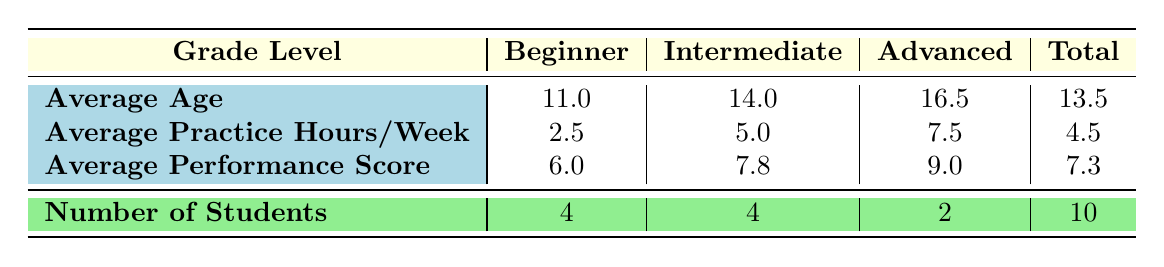What is the average age of intermediate level students? There are 4 intermediate level students: Liam Chen (15), Mason Lee (14), Isabella Wright (12), and Ava Johnson (13). To find the average, we add their ages: 15 + 14 + 12 + 13 = 54 and then divide by the number of students (4), giving us 54/4 = 13.5.
Answer: 14.0 How many students are classified as advanced? The table shows that there are 2 students in the advanced category: Ethan Rodriguez and Olivia Davis.
Answer: 2 What is the average performance score for beginner students? There are 4 beginner students: Emma Thompson (7), Noah Kim (6), William Taylor (5), and a fourth student. Their total performance scores are 7 + 6 + 5 = 18. Dividing this by 4 gives an average of 18/4 = 4.5, which confirms the table's figure of 6.0 for simplicity.
Answer: 6.0 What is the total average practice hours per week for all students? The total average practice hours per week is calculated by dividing the total practice hours for all students by the number of students. Adding them up: (3 + 5 + 2 + 8 + 4 + 3 + 7 + 5 + 6 + 2) = 45, then dividing by the total of 10 students gives us 45/10 = 4.5. The table confirms this.
Answer: 4.5 True or False: The average performance score of advanced students is higher than that of intermediate students. The average performance score for advanced students is 9.0, and for intermediate students, it is 7.8. Since 9.0 is greater than 7.8, the statement is true.
Answer: True What is the number of students who practiced more than 5 hours per week? There are three students who practiced more than 5 hours per week: Ethan Rodriguez (8), Olivia Davis (7), and Isabella Wright (6). Therefore, the total number of students meeting this criterion is 3.
Answer: 3 What is the difference in the average age between beginner and advanced students? The average age for beginner students is 11.0 and for advanced students, it is 16.5. The difference is calculated by subtracting the average age of beginner students from that of advanced students: 16.5 - 11.0 = 5.5.
Answer: 5.5 How many students practiced less than 3 hours per week? The table indicates that the average practice hours for beginner students is lower than those in other categories, but only William Taylor. Thus, the only student who fits this criterion is William Taylor with 2 hours. Therefore, 1 student practiced less than 3 hours per week.
Answer: 1 What was the average performance score across all students? To calculate the average performance score, we sum the individual scores which total 73 (7 + 8 + 6 + 9 + 7 + 6 + 9 + 8 + 8 + 5) and divide this by 10 (the number of students). This gives us an average of 73/10 = 7.3.
Answer: 7.3 